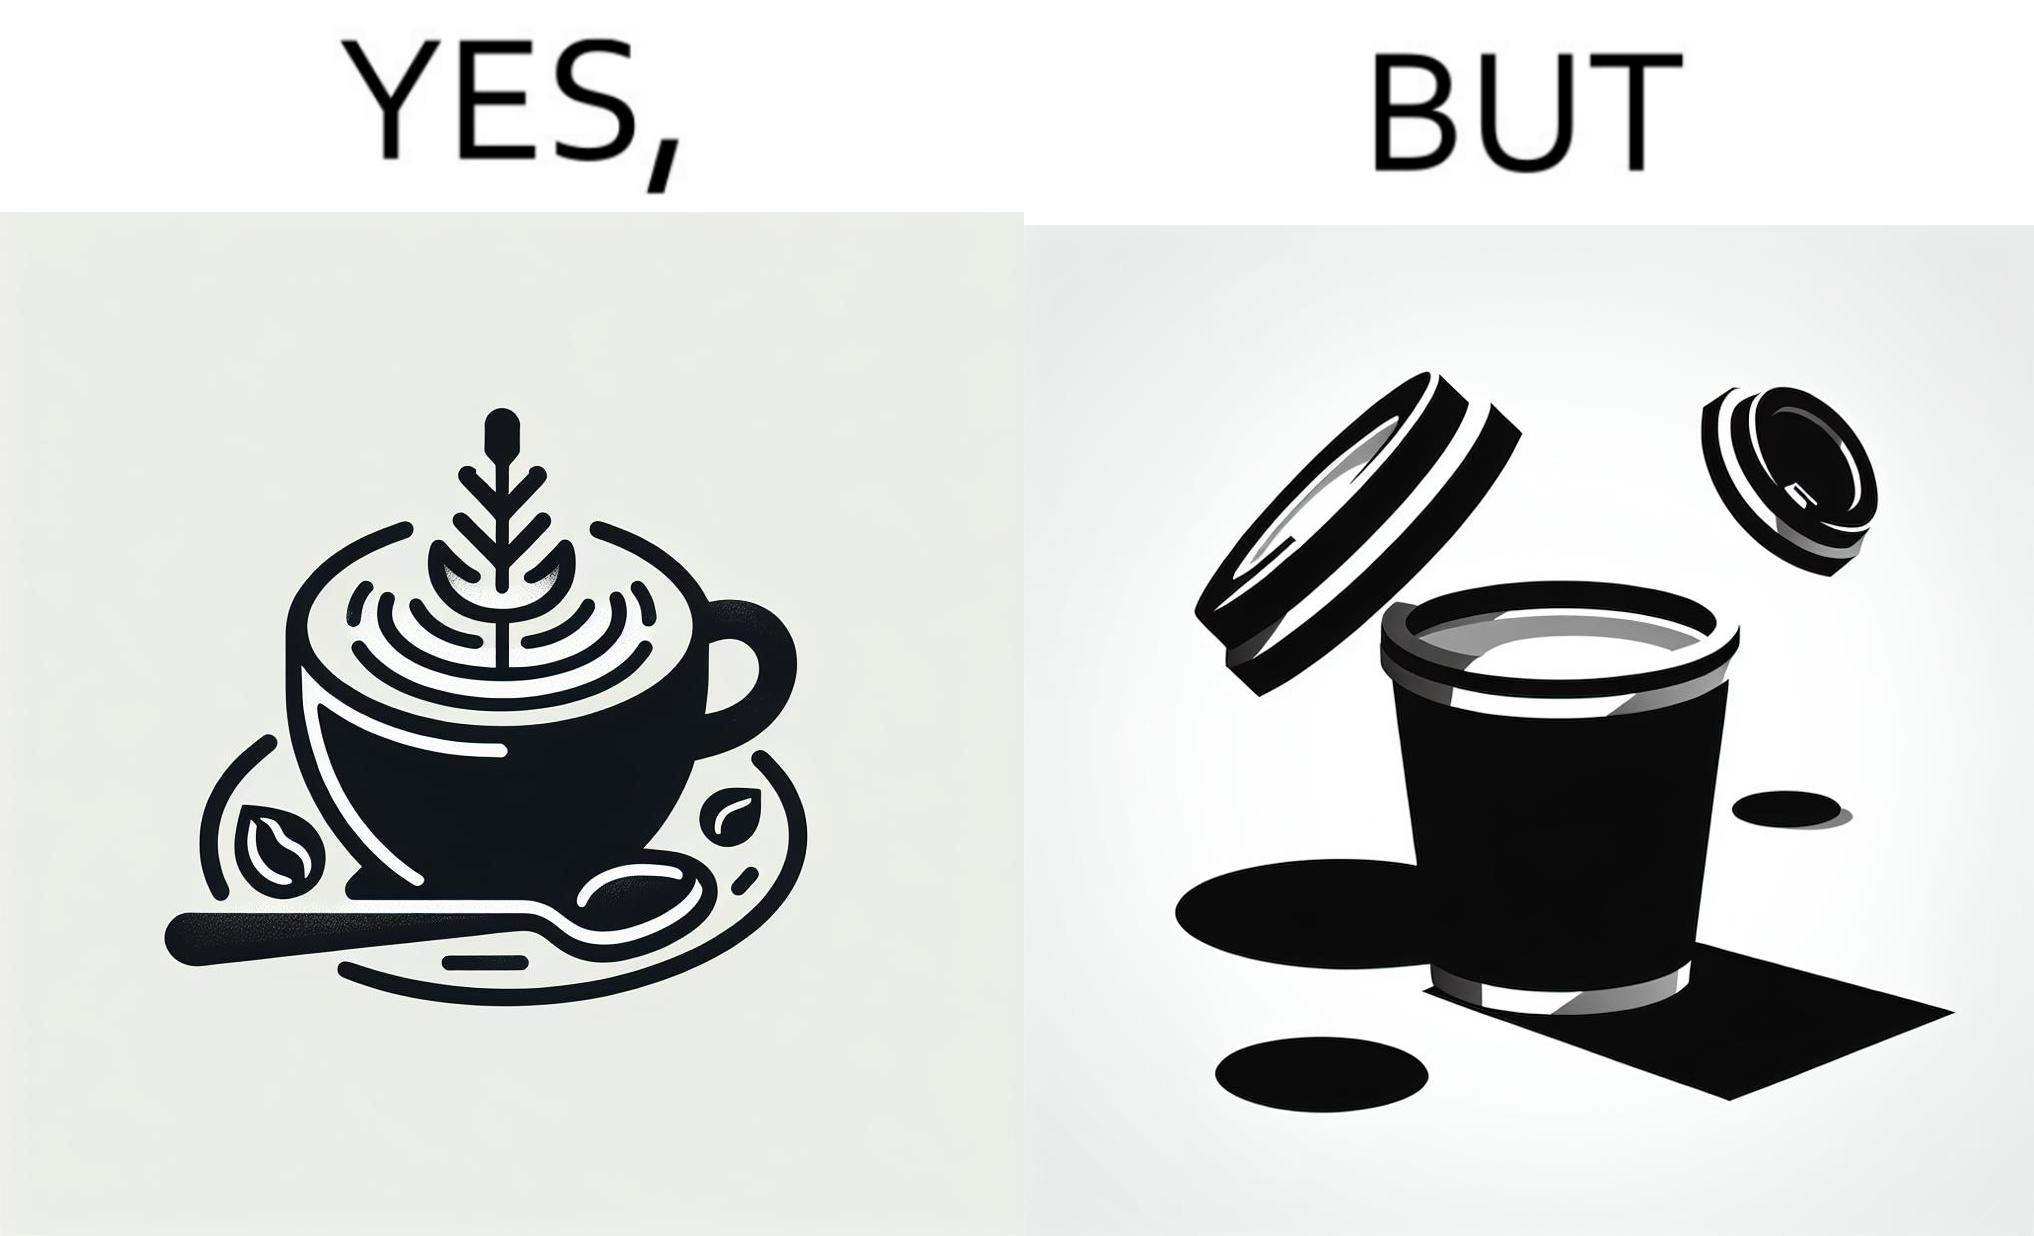What is the satirical meaning behind this image? The images are funny since it shows how someone has put effort into a cup of coffee to do latte art on it only for it to be invisible after a lid is put on the coffee cup before serving to a customer 